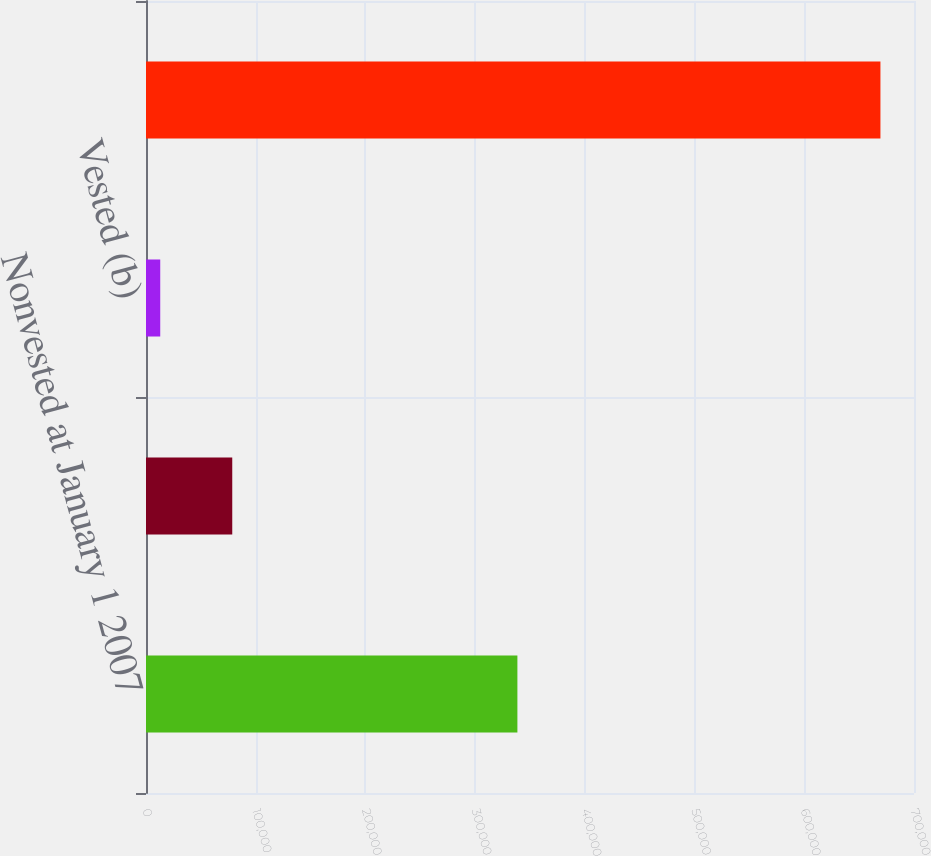<chart> <loc_0><loc_0><loc_500><loc_500><bar_chart><fcel>Nonvested at January 1 2007<fcel>Forfeitures<fcel>Vested (b)<fcel>Nonvested at December 31 2007<nl><fcel>338516<fcel>78617.8<fcel>12975<fcel>669403<nl></chart> 